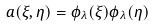Convert formula to latex. <formula><loc_0><loc_0><loc_500><loc_500>a ( \xi , \eta ) = \phi _ { \lambda } ( \xi ) \phi _ { \lambda } ( \eta )</formula> 